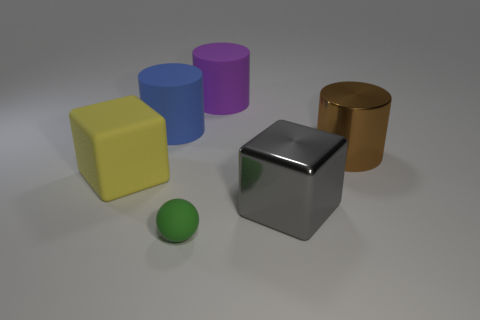Are there any other things that have the same size as the green rubber sphere?
Provide a short and direct response. No. What color is the other cube that is the same size as the yellow block?
Offer a terse response. Gray. What number of other things are the same shape as the big brown shiny thing?
Provide a short and direct response. 2. Do the matte cube and the purple matte cylinder have the same size?
Offer a very short reply. Yes. Is the number of big brown objects on the left side of the blue object greater than the number of yellow cubes that are to the left of the large yellow rubber object?
Offer a terse response. No. How many other things are there of the same size as the green rubber ball?
Make the answer very short. 0. Is the number of objects that are on the right side of the tiny green ball greater than the number of big rubber things?
Make the answer very short. No. Is there any other thing that is the same color as the sphere?
Offer a terse response. No. The metal object behind the cube that is behind the big gray thing is what shape?
Provide a short and direct response. Cylinder. Is the number of large gray things greater than the number of rubber things?
Provide a short and direct response. No. 